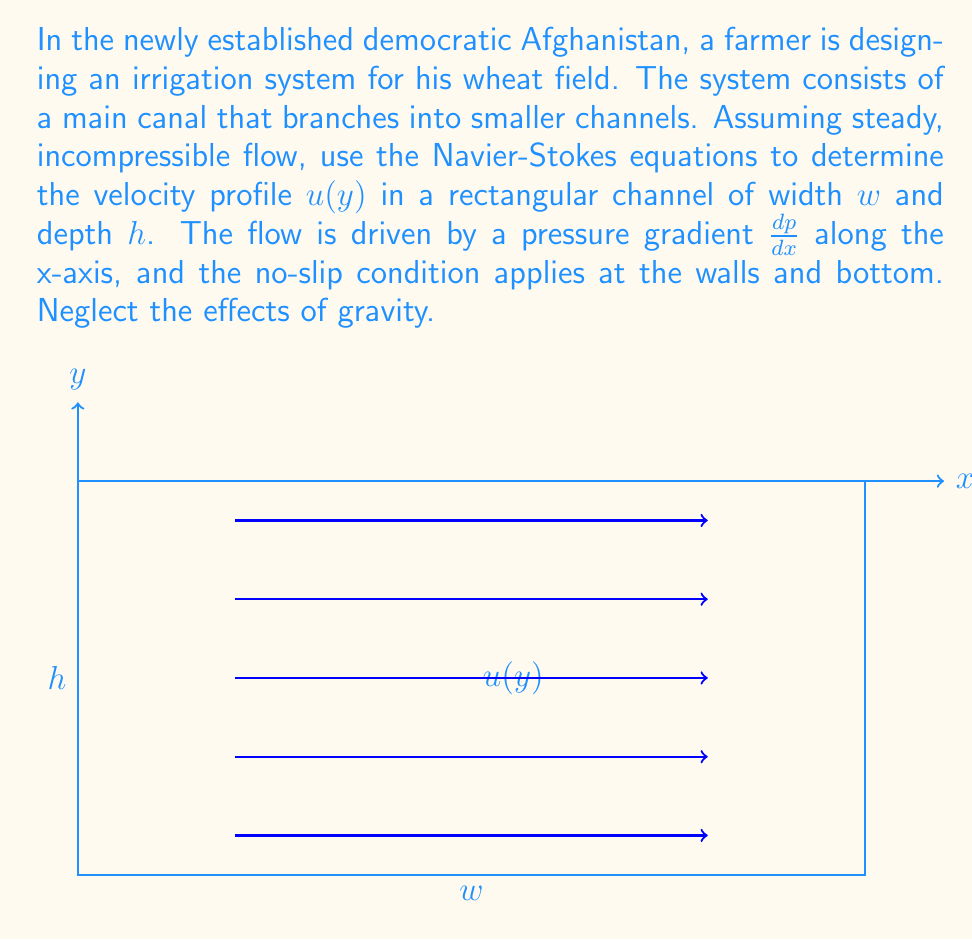Help me with this question. Let's approach this problem step-by-step using the Navier-Stokes equations:

1) For steady, incompressible flow in a rectangular channel, we can simplify the Navier-Stokes equations to:

   $$\mu \frac{d^2u}{dy^2} = \frac{dp}{dx}$$

   where $\mu$ is the dynamic viscosity of water.

2) We need to solve this equation with the following boundary conditions:
   - No-slip at the bottom: $u(0) = 0$
   - No-slip at the top: $u(h) = 0$

3) Integrate the equation twice:

   $$\frac{du}{dy} = \frac{1}{\mu}\frac{dp}{dx}y + C_1$$
   $$u(y) = \frac{1}{2\mu}\frac{dp}{dx}y^2 + C_1y + C_2$$

4) Apply the boundary conditions:

   At $y = 0$: $u(0) = C_2 = 0$
   At $y = h$: $u(h) = \frac{1}{2\mu}\frac{dp}{dx}h^2 + C_1h = 0$

5) Solve for $C_1$:

   $$C_1 = -\frac{1}{2\mu}\frac{dp}{dx}h$$

6) Substitute back into the general solution:

   $$u(y) = \frac{1}{2\mu}\frac{dp}{dx}y^2 - \frac{1}{2\mu}\frac{dp}{dx}hy$$

7) Simplify:

   $$u(y) = \frac{1}{2\mu}\frac{dp}{dx}y(y-h)$$

This equation describes a parabolic velocity profile, which is characteristic of laminar flow in a channel.
Answer: $$u(y) = \frac{1}{2\mu}\frac{dp}{dx}y(y-h)$$ 